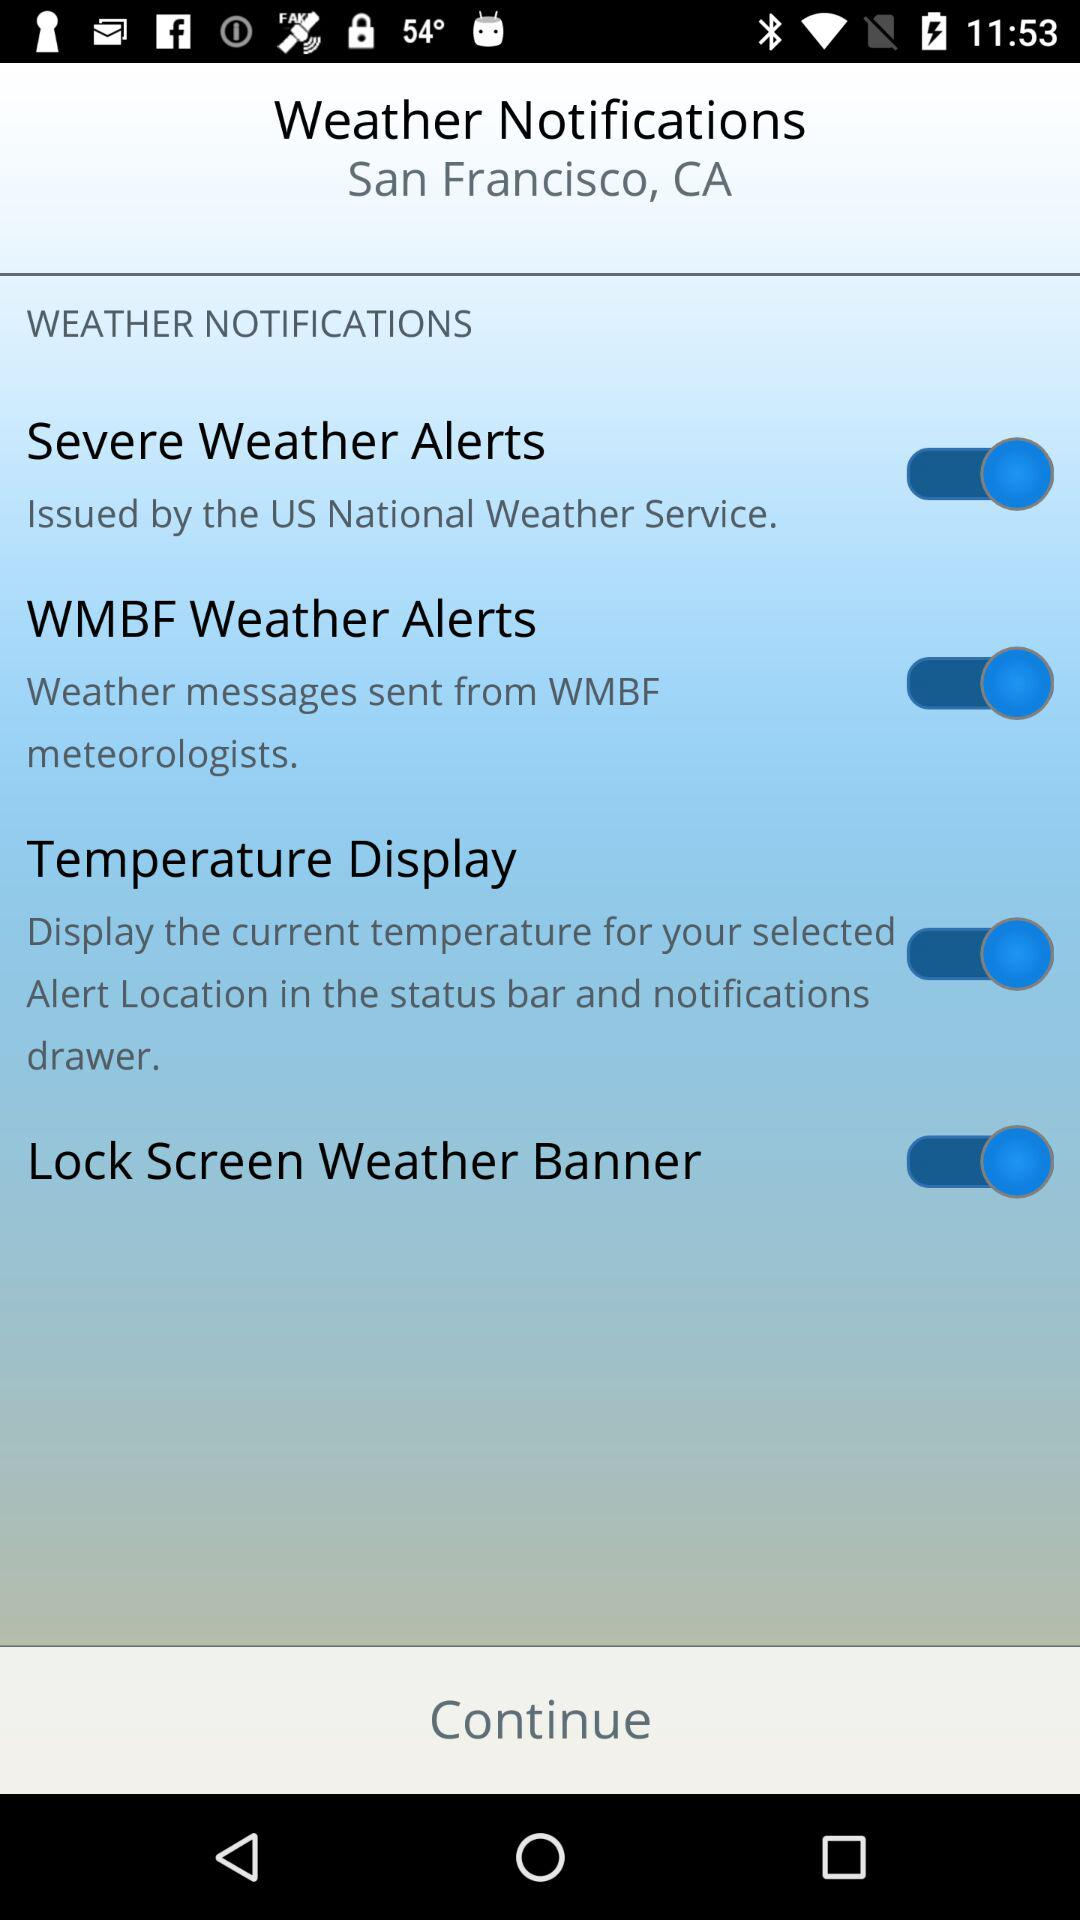What is the status of "Temperature Display"? The status is "on". 